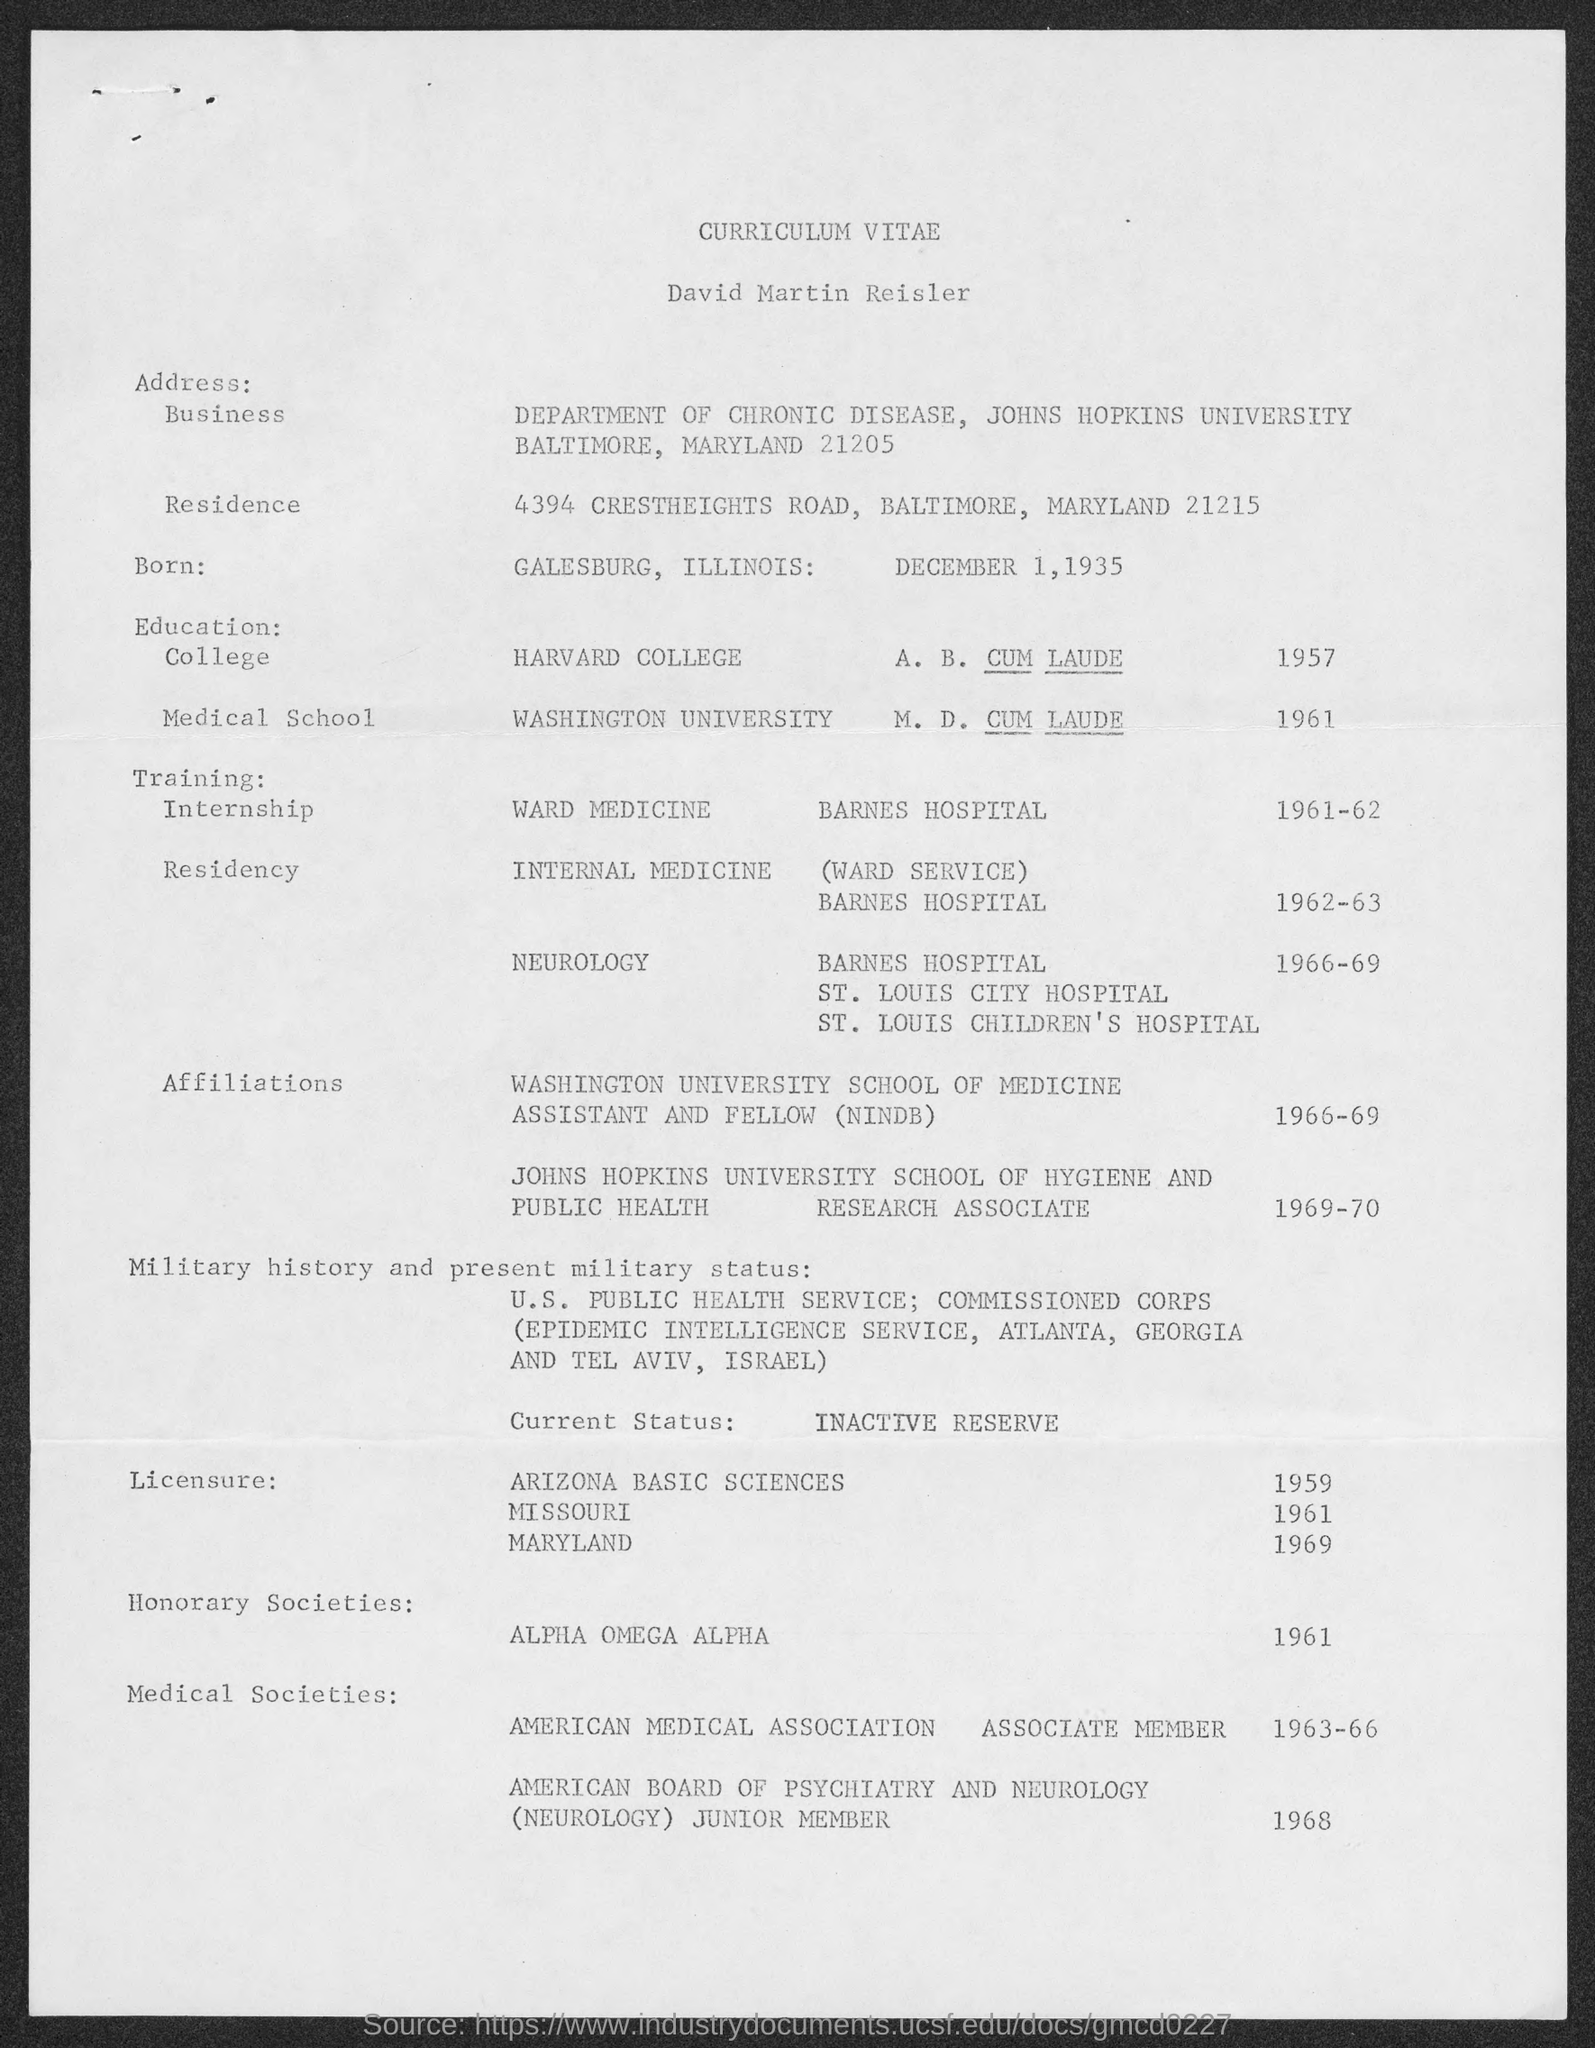Who's Curriculum Vitae is given here?
Your answer should be very brief. David Martin Reisler. What is the date of birth of David Martin Reisler?
Your answer should be very brief. DECEMBER 1, 1935. In which university, David Martin Reisler completed his M.D. Degree?
Your answer should be very brief. WASHINGTON UNIVERSITY. When did David Martin Reisler completed A. B. Dgree from Harvard College?
Make the answer very short. 1957. In which hospital, David Martin Reisler did Residency in Internal Medicine?
Your answer should be very brief. BARNES HOSPITAL. 